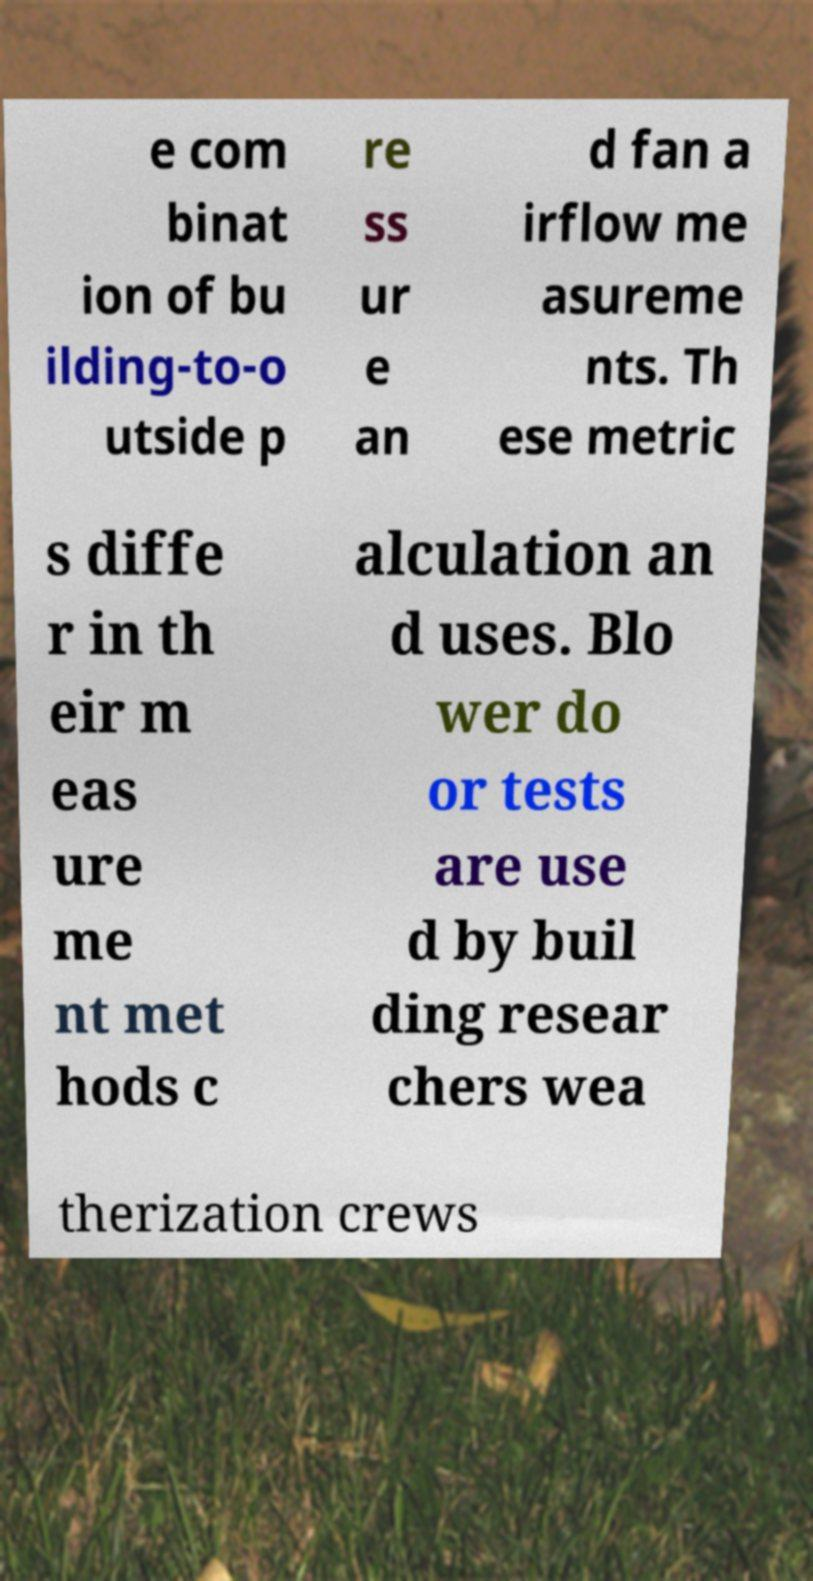I need the written content from this picture converted into text. Can you do that? e com binat ion of bu ilding-to-o utside p re ss ur e an d fan a irflow me asureme nts. Th ese metric s diffe r in th eir m eas ure me nt met hods c alculation an d uses. Blo wer do or tests are use d by buil ding resear chers wea therization crews 